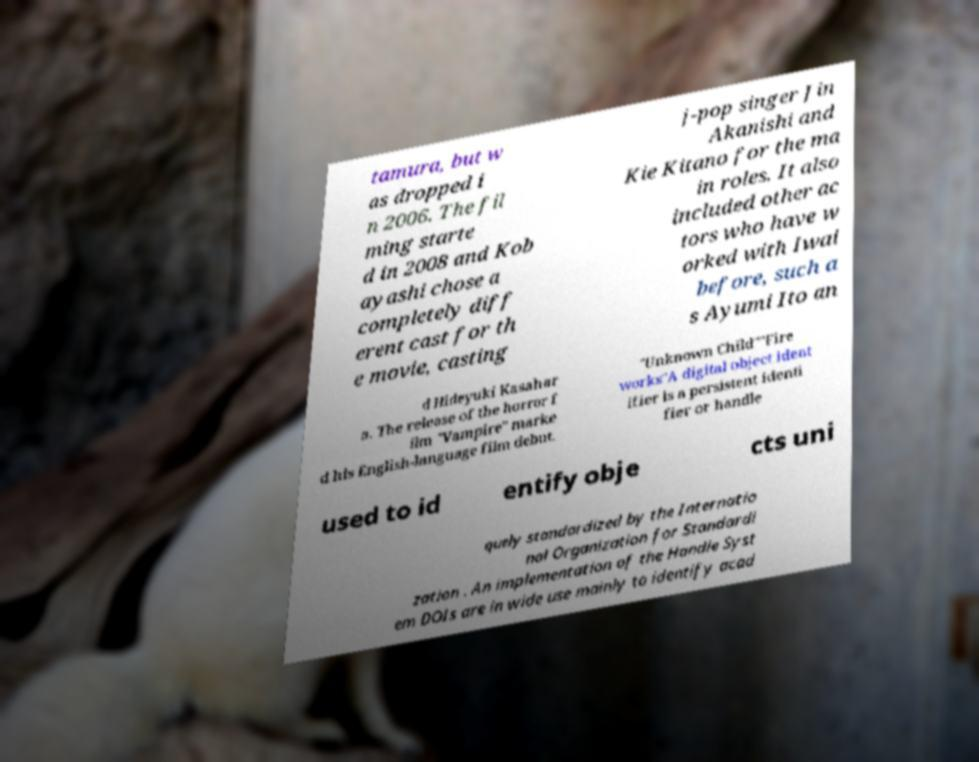Please read and relay the text visible in this image. What does it say? tamura, but w as dropped i n 2006. The fil ming starte d in 2008 and Kob ayashi chose a completely diff erent cast for th e movie, casting j-pop singer Jin Akanishi and Kie Kitano for the ma in roles. It also included other ac tors who have w orked with Iwai before, such a s Ayumi Ito an d Hideyuki Kasahar a. The release of the horror f ilm "Vampire" marke d his English-language film debut. "Unknown Child""Fire works"A digital object ident ifier is a persistent identi fier or handle used to id entify obje cts uni quely standardized by the Internatio nal Organization for Standardi zation . An implementation of the Handle Syst em DOIs are in wide use mainly to identify acad 